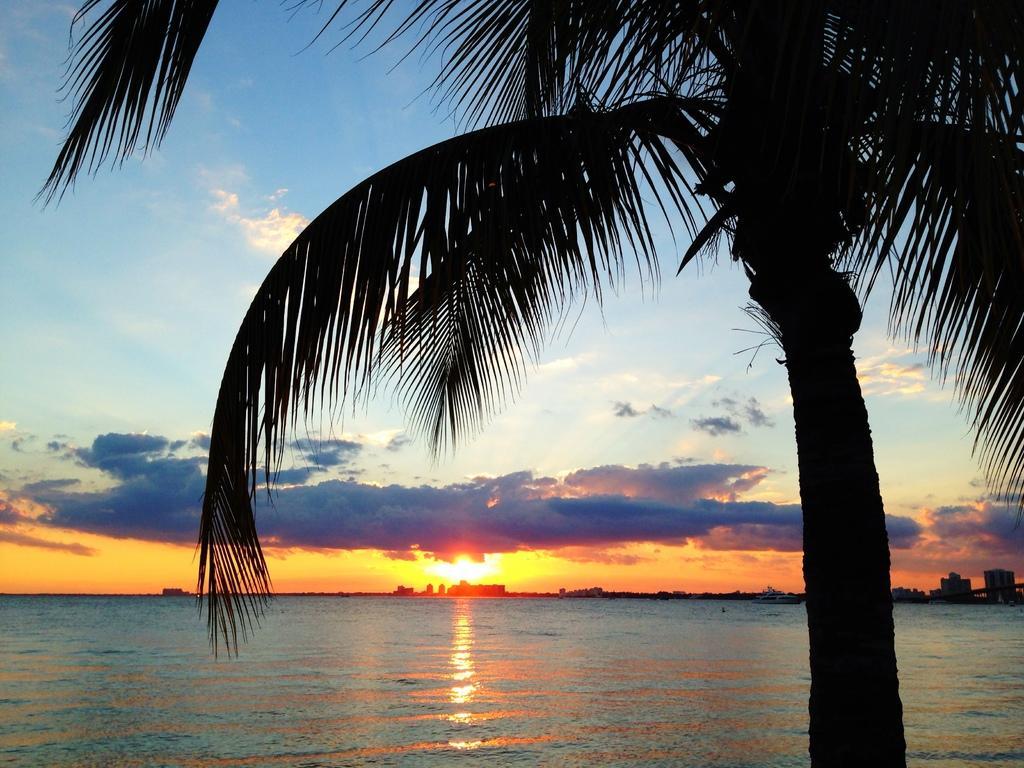In one or two sentences, can you explain what this image depicts? In the picture we can see a tree with a leaf and in the background, we can see a water and far away from it we can see a sunshine and sky with clouds. 